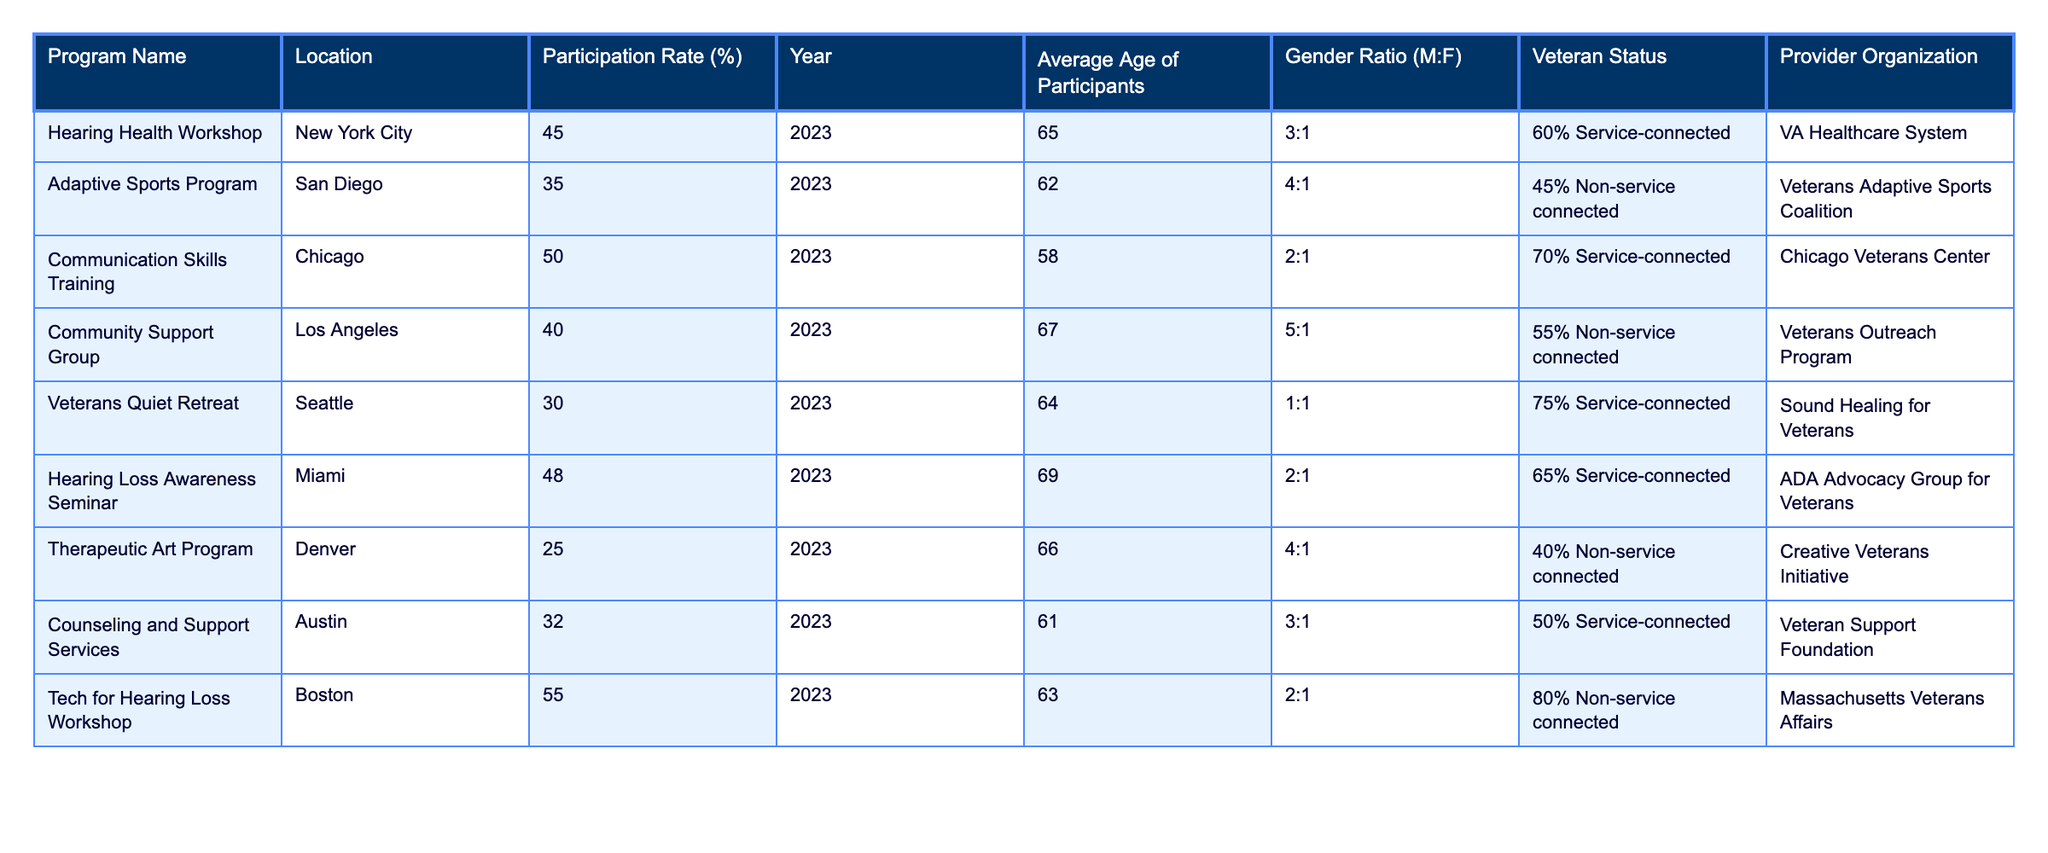What is the highest participation rate among the programs listed? By examining the table, the program with the highest participation rate is the Tech for Hearing Loss Workshop, which has a rate of 55%.
Answer: 55% Which program has the lowest participation rate and what is that rate? The program with the lowest participation rate is the Therapeutic Art Program, which has a rate of 25%.
Answer: 25% What is the average age of participants in the Community Support Group? The average age of participants in the Community Support Group is 67 years, as stated in the table.
Answer: 67 Is the ratio of male to female participants equal for the Veterans Quiet Retreat program? The ratio of male to female participants in the Veterans Quiet Retreat program is 1:1, which indicates it is equal.
Answer: Yes How many programs have a participation rate higher than 40%? There are four programs with a participation rate higher than 40%: Hearing Health Workshop (45%), Communication Skills Training (50%), Hearing Loss Awareness Seminar (48%), and Tech for Hearing Loss Workshop (55%).
Answer: 4 What is the average participation rate of all programs listed? To find the average, sum the participation rates (45 + 35 + 50 + 40 + 30 + 48 + 25 + 32 + 55) = 365. Since there are 9 programs, the average is 365 / 9 = 40.56.
Answer: 40.56 Which program has the highest average age of participants? The program with the highest average age is the Hearing Loss Awareness Seminar with an average age of 69 years.
Answer: Hearing Loss Awareness Seminar Do any of the programs have a participation rate below the average participation rate determined earlier? The average participation rate is approximately 40.56, and programs below this rate include Adaptive Sports Program (35%), Veterans Quiet Retreat (30%), and Therapeutic Art Program (25%).
Answer: Yes Which provider organization is associated with the Communication Skills Training program? The Communication Skills Training program is associated with the Chicago Veterans Center, as noted in the table.
Answer: Chicago Veterans Center What is the participation rate difference between the Tech for Hearing Loss Workshop and the Adaptive Sports Program? The participation rate for the Tech for Hearing Loss Workshop is 55%, while the Adaptive Sports Program's rate is 35%. The difference is 55 - 35 = 20.
Answer: 20 